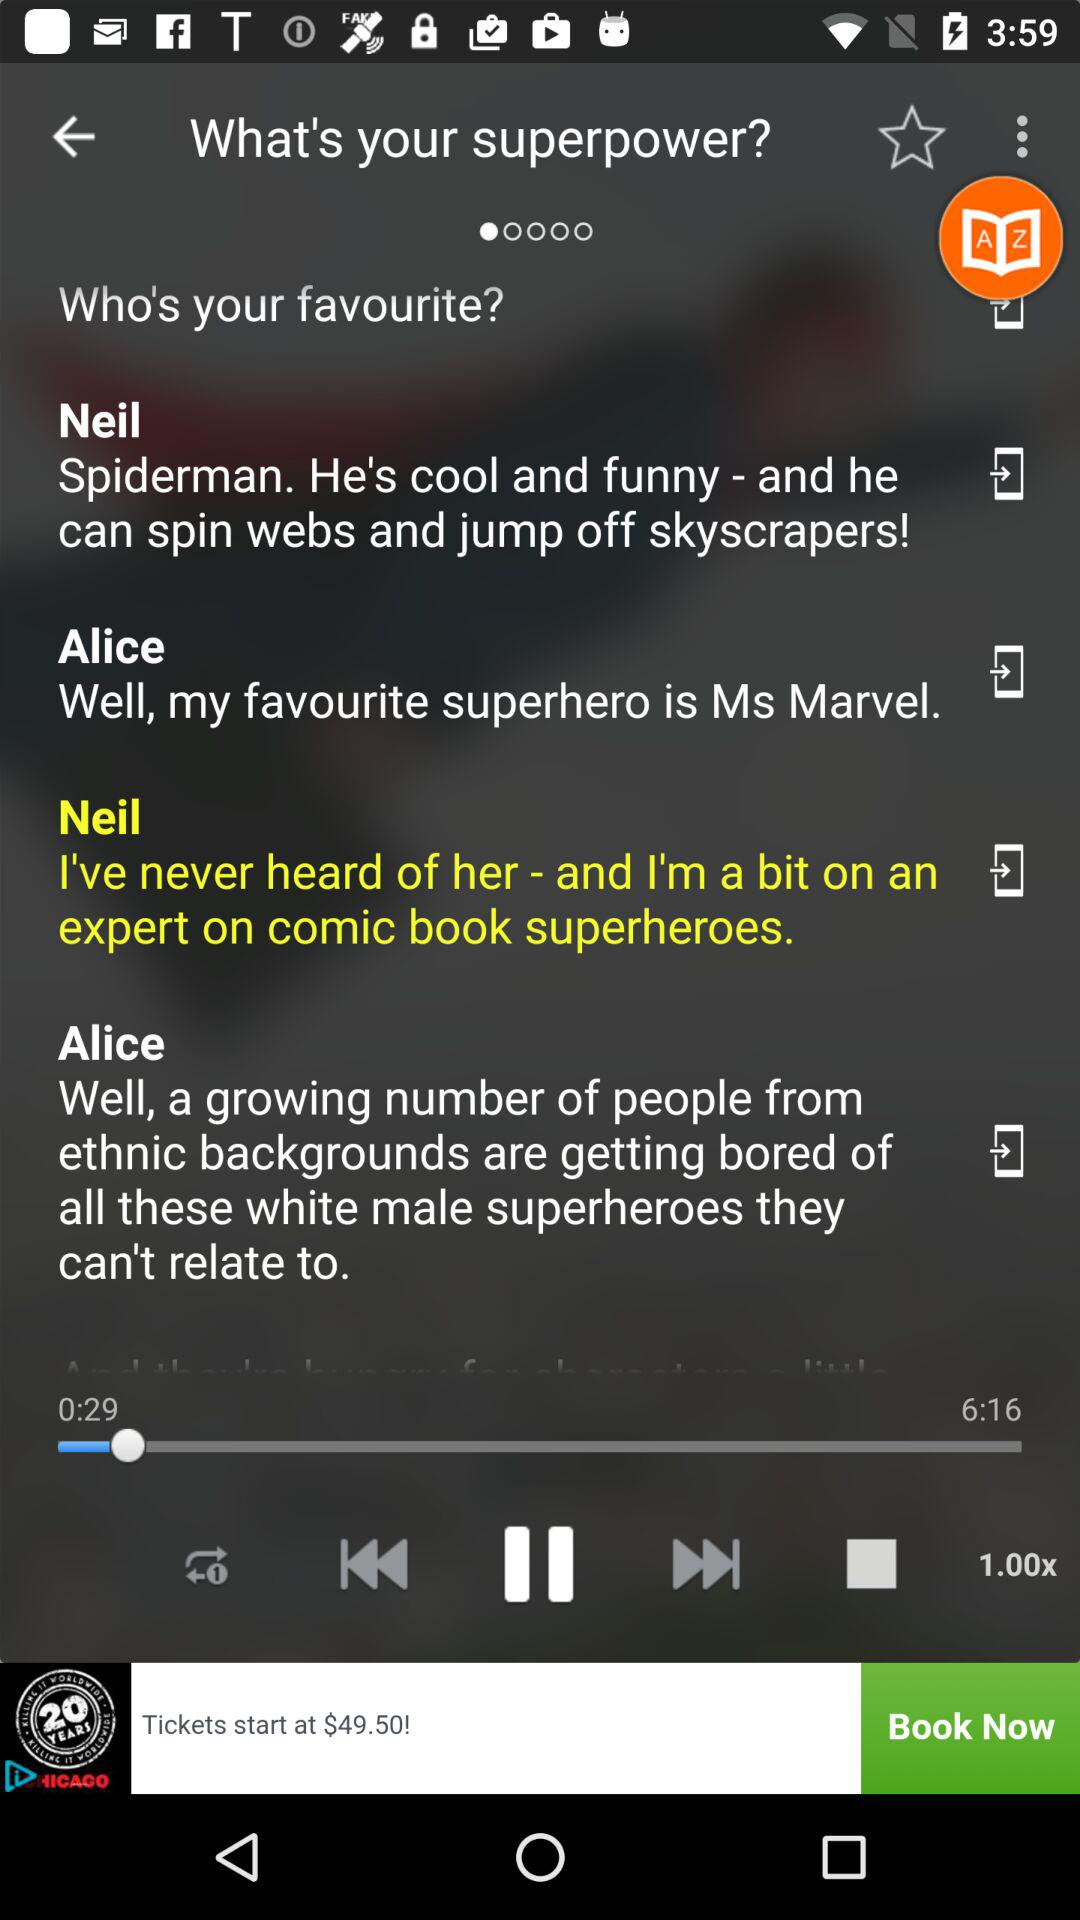What's the name of this application?
When the provided information is insufficient, respond with <no answer>. <no answer> 